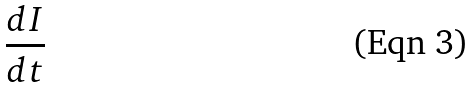<formula> <loc_0><loc_0><loc_500><loc_500>\frac { d I } { d t }</formula> 